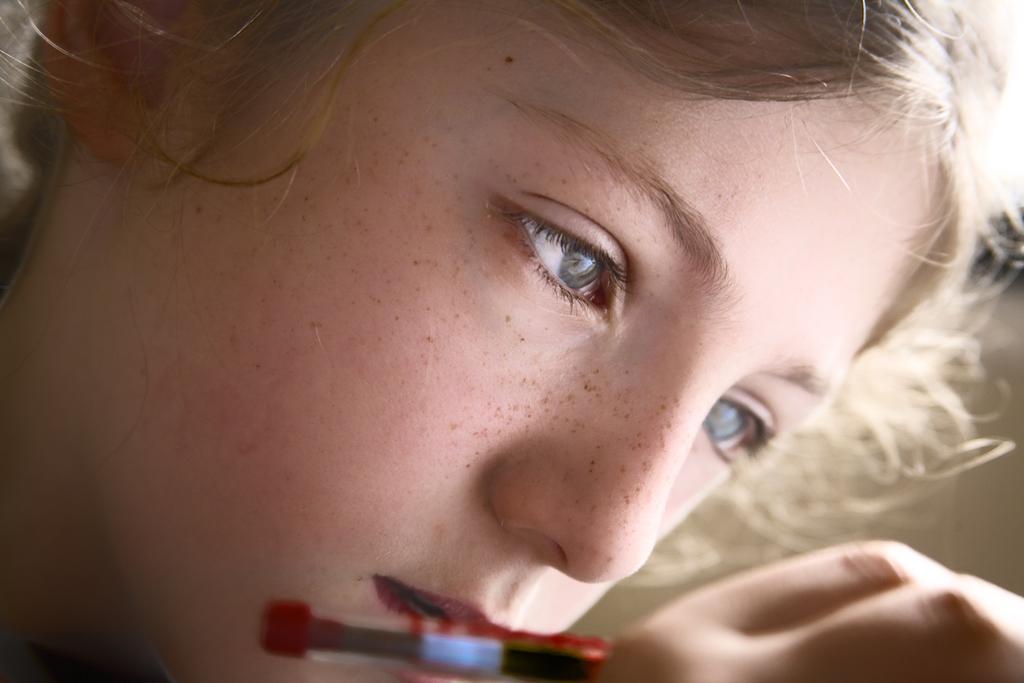Describe this image in one or two sentences. In this picture there is a girl who is holding a painting brush. At the top we can see the hairs. 